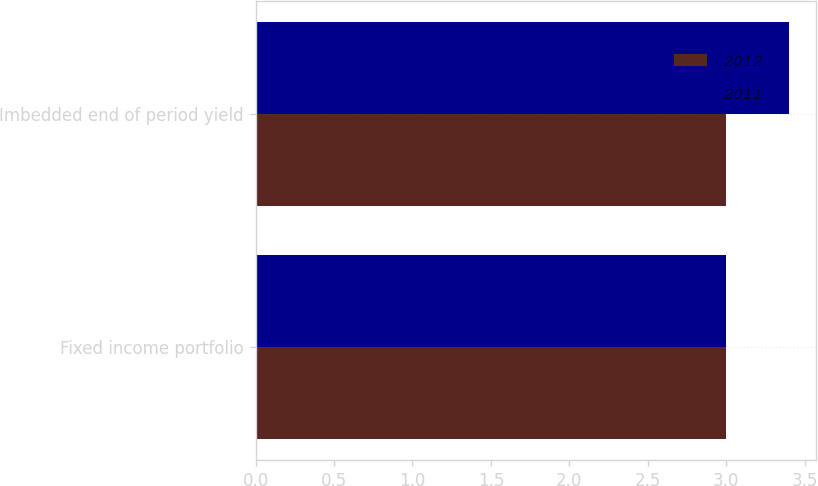<chart> <loc_0><loc_0><loc_500><loc_500><stacked_bar_chart><ecel><fcel>Fixed income portfolio<fcel>Imbedded end of period yield<nl><fcel>2012<fcel>3<fcel>3<nl><fcel>2011<fcel>3<fcel>3.4<nl></chart> 